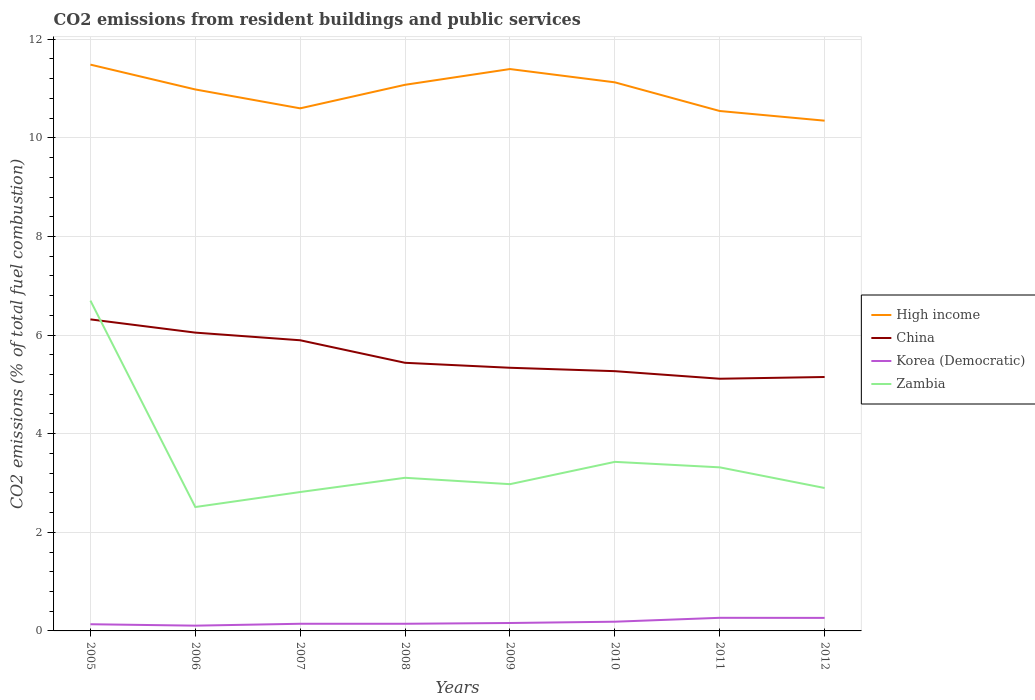Is the number of lines equal to the number of legend labels?
Provide a succinct answer. Yes. Across all years, what is the maximum total CO2 emitted in High income?
Your answer should be very brief. 10.35. What is the total total CO2 emitted in Zambia in the graph?
Your answer should be very brief. -0.45. What is the difference between the highest and the second highest total CO2 emitted in China?
Your answer should be very brief. 1.2. What is the difference between the highest and the lowest total CO2 emitted in Korea (Democratic)?
Offer a terse response. 3. How many years are there in the graph?
Keep it short and to the point. 8. What is the difference between two consecutive major ticks on the Y-axis?
Your answer should be compact. 2. Are the values on the major ticks of Y-axis written in scientific E-notation?
Keep it short and to the point. No. Does the graph contain grids?
Provide a short and direct response. Yes. Where does the legend appear in the graph?
Offer a very short reply. Center right. How are the legend labels stacked?
Your answer should be compact. Vertical. What is the title of the graph?
Your response must be concise. CO2 emissions from resident buildings and public services. Does "Sint Maarten (Dutch part)" appear as one of the legend labels in the graph?
Provide a succinct answer. No. What is the label or title of the X-axis?
Your response must be concise. Years. What is the label or title of the Y-axis?
Offer a terse response. CO2 emissions (% of total fuel combustion). What is the CO2 emissions (% of total fuel combustion) of High income in 2005?
Keep it short and to the point. 11.48. What is the CO2 emissions (% of total fuel combustion) of China in 2005?
Provide a succinct answer. 6.32. What is the CO2 emissions (% of total fuel combustion) of Korea (Democratic) in 2005?
Give a very brief answer. 0.14. What is the CO2 emissions (% of total fuel combustion) in Zambia in 2005?
Ensure brevity in your answer.  6.7. What is the CO2 emissions (% of total fuel combustion) of High income in 2006?
Your answer should be very brief. 10.98. What is the CO2 emissions (% of total fuel combustion) of China in 2006?
Keep it short and to the point. 6.05. What is the CO2 emissions (% of total fuel combustion) in Korea (Democratic) in 2006?
Your answer should be compact. 0.11. What is the CO2 emissions (% of total fuel combustion) of Zambia in 2006?
Ensure brevity in your answer.  2.51. What is the CO2 emissions (% of total fuel combustion) of High income in 2007?
Offer a terse response. 10.6. What is the CO2 emissions (% of total fuel combustion) of China in 2007?
Your answer should be compact. 5.89. What is the CO2 emissions (% of total fuel combustion) of Korea (Democratic) in 2007?
Give a very brief answer. 0.15. What is the CO2 emissions (% of total fuel combustion) of Zambia in 2007?
Your answer should be compact. 2.82. What is the CO2 emissions (% of total fuel combustion) of High income in 2008?
Provide a succinct answer. 11.08. What is the CO2 emissions (% of total fuel combustion) in China in 2008?
Make the answer very short. 5.44. What is the CO2 emissions (% of total fuel combustion) of Korea (Democratic) in 2008?
Your answer should be compact. 0.15. What is the CO2 emissions (% of total fuel combustion) in Zambia in 2008?
Your response must be concise. 3.11. What is the CO2 emissions (% of total fuel combustion) in High income in 2009?
Make the answer very short. 11.4. What is the CO2 emissions (% of total fuel combustion) of China in 2009?
Ensure brevity in your answer.  5.34. What is the CO2 emissions (% of total fuel combustion) of Korea (Democratic) in 2009?
Keep it short and to the point. 0.16. What is the CO2 emissions (% of total fuel combustion) in Zambia in 2009?
Offer a terse response. 2.98. What is the CO2 emissions (% of total fuel combustion) in High income in 2010?
Your answer should be compact. 11.13. What is the CO2 emissions (% of total fuel combustion) in China in 2010?
Your response must be concise. 5.27. What is the CO2 emissions (% of total fuel combustion) of Korea (Democratic) in 2010?
Your answer should be very brief. 0.19. What is the CO2 emissions (% of total fuel combustion) of Zambia in 2010?
Your answer should be compact. 3.43. What is the CO2 emissions (% of total fuel combustion) in High income in 2011?
Ensure brevity in your answer.  10.54. What is the CO2 emissions (% of total fuel combustion) in China in 2011?
Give a very brief answer. 5.11. What is the CO2 emissions (% of total fuel combustion) in Korea (Democratic) in 2011?
Your response must be concise. 0.27. What is the CO2 emissions (% of total fuel combustion) of Zambia in 2011?
Offer a terse response. 3.32. What is the CO2 emissions (% of total fuel combustion) of High income in 2012?
Offer a terse response. 10.35. What is the CO2 emissions (% of total fuel combustion) in China in 2012?
Ensure brevity in your answer.  5.15. What is the CO2 emissions (% of total fuel combustion) in Korea (Democratic) in 2012?
Ensure brevity in your answer.  0.26. What is the CO2 emissions (% of total fuel combustion) of Zambia in 2012?
Your answer should be compact. 2.9. Across all years, what is the maximum CO2 emissions (% of total fuel combustion) of High income?
Make the answer very short. 11.48. Across all years, what is the maximum CO2 emissions (% of total fuel combustion) of China?
Make the answer very short. 6.32. Across all years, what is the maximum CO2 emissions (% of total fuel combustion) in Korea (Democratic)?
Ensure brevity in your answer.  0.27. Across all years, what is the maximum CO2 emissions (% of total fuel combustion) in Zambia?
Make the answer very short. 6.7. Across all years, what is the minimum CO2 emissions (% of total fuel combustion) of High income?
Keep it short and to the point. 10.35. Across all years, what is the minimum CO2 emissions (% of total fuel combustion) in China?
Your answer should be compact. 5.11. Across all years, what is the minimum CO2 emissions (% of total fuel combustion) in Korea (Democratic)?
Offer a terse response. 0.11. Across all years, what is the minimum CO2 emissions (% of total fuel combustion) of Zambia?
Your answer should be compact. 2.51. What is the total CO2 emissions (% of total fuel combustion) in High income in the graph?
Offer a terse response. 87.55. What is the total CO2 emissions (% of total fuel combustion) in China in the graph?
Your answer should be compact. 44.57. What is the total CO2 emissions (% of total fuel combustion) of Korea (Democratic) in the graph?
Give a very brief answer. 1.41. What is the total CO2 emissions (% of total fuel combustion) of Zambia in the graph?
Your answer should be compact. 27.75. What is the difference between the CO2 emissions (% of total fuel combustion) in High income in 2005 and that in 2006?
Keep it short and to the point. 0.5. What is the difference between the CO2 emissions (% of total fuel combustion) in China in 2005 and that in 2006?
Keep it short and to the point. 0.27. What is the difference between the CO2 emissions (% of total fuel combustion) of Korea (Democratic) in 2005 and that in 2006?
Ensure brevity in your answer.  0.03. What is the difference between the CO2 emissions (% of total fuel combustion) of Zambia in 2005 and that in 2006?
Your response must be concise. 4.19. What is the difference between the CO2 emissions (% of total fuel combustion) of High income in 2005 and that in 2007?
Your response must be concise. 0.89. What is the difference between the CO2 emissions (% of total fuel combustion) in China in 2005 and that in 2007?
Give a very brief answer. 0.42. What is the difference between the CO2 emissions (% of total fuel combustion) of Korea (Democratic) in 2005 and that in 2007?
Give a very brief answer. -0.01. What is the difference between the CO2 emissions (% of total fuel combustion) of Zambia in 2005 and that in 2007?
Your response must be concise. 3.88. What is the difference between the CO2 emissions (% of total fuel combustion) of High income in 2005 and that in 2008?
Ensure brevity in your answer.  0.41. What is the difference between the CO2 emissions (% of total fuel combustion) in China in 2005 and that in 2008?
Provide a short and direct response. 0.88. What is the difference between the CO2 emissions (% of total fuel combustion) of Korea (Democratic) in 2005 and that in 2008?
Ensure brevity in your answer.  -0.01. What is the difference between the CO2 emissions (% of total fuel combustion) in Zambia in 2005 and that in 2008?
Ensure brevity in your answer.  3.59. What is the difference between the CO2 emissions (% of total fuel combustion) in High income in 2005 and that in 2009?
Offer a terse response. 0.09. What is the difference between the CO2 emissions (% of total fuel combustion) of China in 2005 and that in 2009?
Offer a very short reply. 0.98. What is the difference between the CO2 emissions (% of total fuel combustion) in Korea (Democratic) in 2005 and that in 2009?
Provide a succinct answer. -0.03. What is the difference between the CO2 emissions (% of total fuel combustion) in Zambia in 2005 and that in 2009?
Keep it short and to the point. 3.72. What is the difference between the CO2 emissions (% of total fuel combustion) of High income in 2005 and that in 2010?
Provide a short and direct response. 0.36. What is the difference between the CO2 emissions (% of total fuel combustion) of China in 2005 and that in 2010?
Ensure brevity in your answer.  1.05. What is the difference between the CO2 emissions (% of total fuel combustion) of Korea (Democratic) in 2005 and that in 2010?
Ensure brevity in your answer.  -0.05. What is the difference between the CO2 emissions (% of total fuel combustion) in Zambia in 2005 and that in 2010?
Give a very brief answer. 3.27. What is the difference between the CO2 emissions (% of total fuel combustion) in High income in 2005 and that in 2011?
Your answer should be very brief. 0.94. What is the difference between the CO2 emissions (% of total fuel combustion) in China in 2005 and that in 2011?
Ensure brevity in your answer.  1.2. What is the difference between the CO2 emissions (% of total fuel combustion) in Korea (Democratic) in 2005 and that in 2011?
Offer a terse response. -0.13. What is the difference between the CO2 emissions (% of total fuel combustion) of Zambia in 2005 and that in 2011?
Offer a terse response. 3.38. What is the difference between the CO2 emissions (% of total fuel combustion) of High income in 2005 and that in 2012?
Your answer should be compact. 1.14. What is the difference between the CO2 emissions (% of total fuel combustion) in China in 2005 and that in 2012?
Provide a short and direct response. 1.17. What is the difference between the CO2 emissions (% of total fuel combustion) of Korea (Democratic) in 2005 and that in 2012?
Ensure brevity in your answer.  -0.13. What is the difference between the CO2 emissions (% of total fuel combustion) in Zambia in 2005 and that in 2012?
Offer a very short reply. 3.8. What is the difference between the CO2 emissions (% of total fuel combustion) in High income in 2006 and that in 2007?
Your answer should be compact. 0.38. What is the difference between the CO2 emissions (% of total fuel combustion) in China in 2006 and that in 2007?
Provide a succinct answer. 0.16. What is the difference between the CO2 emissions (% of total fuel combustion) in Korea (Democratic) in 2006 and that in 2007?
Ensure brevity in your answer.  -0.04. What is the difference between the CO2 emissions (% of total fuel combustion) in Zambia in 2006 and that in 2007?
Offer a very short reply. -0.3. What is the difference between the CO2 emissions (% of total fuel combustion) in High income in 2006 and that in 2008?
Your response must be concise. -0.09. What is the difference between the CO2 emissions (% of total fuel combustion) in China in 2006 and that in 2008?
Offer a very short reply. 0.61. What is the difference between the CO2 emissions (% of total fuel combustion) of Korea (Democratic) in 2006 and that in 2008?
Keep it short and to the point. -0.04. What is the difference between the CO2 emissions (% of total fuel combustion) in Zambia in 2006 and that in 2008?
Ensure brevity in your answer.  -0.59. What is the difference between the CO2 emissions (% of total fuel combustion) in High income in 2006 and that in 2009?
Your answer should be compact. -0.41. What is the difference between the CO2 emissions (% of total fuel combustion) of China in 2006 and that in 2009?
Provide a succinct answer. 0.71. What is the difference between the CO2 emissions (% of total fuel combustion) of Korea (Democratic) in 2006 and that in 2009?
Offer a very short reply. -0.05. What is the difference between the CO2 emissions (% of total fuel combustion) in Zambia in 2006 and that in 2009?
Provide a short and direct response. -0.46. What is the difference between the CO2 emissions (% of total fuel combustion) in High income in 2006 and that in 2010?
Provide a short and direct response. -0.14. What is the difference between the CO2 emissions (% of total fuel combustion) in China in 2006 and that in 2010?
Provide a short and direct response. 0.78. What is the difference between the CO2 emissions (% of total fuel combustion) of Korea (Democratic) in 2006 and that in 2010?
Offer a very short reply. -0.08. What is the difference between the CO2 emissions (% of total fuel combustion) of Zambia in 2006 and that in 2010?
Your response must be concise. -0.92. What is the difference between the CO2 emissions (% of total fuel combustion) of High income in 2006 and that in 2011?
Offer a very short reply. 0.44. What is the difference between the CO2 emissions (% of total fuel combustion) in China in 2006 and that in 2011?
Your response must be concise. 0.94. What is the difference between the CO2 emissions (% of total fuel combustion) in Korea (Democratic) in 2006 and that in 2011?
Ensure brevity in your answer.  -0.16. What is the difference between the CO2 emissions (% of total fuel combustion) in Zambia in 2006 and that in 2011?
Ensure brevity in your answer.  -0.81. What is the difference between the CO2 emissions (% of total fuel combustion) of High income in 2006 and that in 2012?
Keep it short and to the point. 0.63. What is the difference between the CO2 emissions (% of total fuel combustion) of China in 2006 and that in 2012?
Provide a succinct answer. 0.9. What is the difference between the CO2 emissions (% of total fuel combustion) of Korea (Democratic) in 2006 and that in 2012?
Make the answer very short. -0.16. What is the difference between the CO2 emissions (% of total fuel combustion) of Zambia in 2006 and that in 2012?
Offer a terse response. -0.39. What is the difference between the CO2 emissions (% of total fuel combustion) of High income in 2007 and that in 2008?
Your answer should be compact. -0.48. What is the difference between the CO2 emissions (% of total fuel combustion) of China in 2007 and that in 2008?
Your answer should be compact. 0.46. What is the difference between the CO2 emissions (% of total fuel combustion) in Korea (Democratic) in 2007 and that in 2008?
Offer a terse response. 0. What is the difference between the CO2 emissions (% of total fuel combustion) in Zambia in 2007 and that in 2008?
Provide a short and direct response. -0.29. What is the difference between the CO2 emissions (% of total fuel combustion) in High income in 2007 and that in 2009?
Provide a short and direct response. -0.8. What is the difference between the CO2 emissions (% of total fuel combustion) of China in 2007 and that in 2009?
Ensure brevity in your answer.  0.56. What is the difference between the CO2 emissions (% of total fuel combustion) of Korea (Democratic) in 2007 and that in 2009?
Provide a short and direct response. -0.02. What is the difference between the CO2 emissions (% of total fuel combustion) of Zambia in 2007 and that in 2009?
Ensure brevity in your answer.  -0.16. What is the difference between the CO2 emissions (% of total fuel combustion) in High income in 2007 and that in 2010?
Make the answer very short. -0.53. What is the difference between the CO2 emissions (% of total fuel combustion) in China in 2007 and that in 2010?
Keep it short and to the point. 0.63. What is the difference between the CO2 emissions (% of total fuel combustion) in Korea (Democratic) in 2007 and that in 2010?
Your answer should be very brief. -0.04. What is the difference between the CO2 emissions (% of total fuel combustion) of Zambia in 2007 and that in 2010?
Your answer should be very brief. -0.61. What is the difference between the CO2 emissions (% of total fuel combustion) of High income in 2007 and that in 2011?
Provide a succinct answer. 0.05. What is the difference between the CO2 emissions (% of total fuel combustion) of China in 2007 and that in 2011?
Offer a terse response. 0.78. What is the difference between the CO2 emissions (% of total fuel combustion) in Korea (Democratic) in 2007 and that in 2011?
Your response must be concise. -0.12. What is the difference between the CO2 emissions (% of total fuel combustion) in Zambia in 2007 and that in 2011?
Give a very brief answer. -0.5. What is the difference between the CO2 emissions (% of total fuel combustion) of High income in 2007 and that in 2012?
Offer a terse response. 0.25. What is the difference between the CO2 emissions (% of total fuel combustion) of China in 2007 and that in 2012?
Offer a terse response. 0.74. What is the difference between the CO2 emissions (% of total fuel combustion) in Korea (Democratic) in 2007 and that in 2012?
Ensure brevity in your answer.  -0.12. What is the difference between the CO2 emissions (% of total fuel combustion) in Zambia in 2007 and that in 2012?
Your response must be concise. -0.08. What is the difference between the CO2 emissions (% of total fuel combustion) of High income in 2008 and that in 2009?
Provide a short and direct response. -0.32. What is the difference between the CO2 emissions (% of total fuel combustion) of China in 2008 and that in 2009?
Offer a terse response. 0.1. What is the difference between the CO2 emissions (% of total fuel combustion) in Korea (Democratic) in 2008 and that in 2009?
Your answer should be compact. -0.02. What is the difference between the CO2 emissions (% of total fuel combustion) in Zambia in 2008 and that in 2009?
Make the answer very short. 0.13. What is the difference between the CO2 emissions (% of total fuel combustion) in High income in 2008 and that in 2010?
Provide a succinct answer. -0.05. What is the difference between the CO2 emissions (% of total fuel combustion) in China in 2008 and that in 2010?
Offer a very short reply. 0.17. What is the difference between the CO2 emissions (% of total fuel combustion) of Korea (Democratic) in 2008 and that in 2010?
Provide a short and direct response. -0.04. What is the difference between the CO2 emissions (% of total fuel combustion) of Zambia in 2008 and that in 2010?
Make the answer very short. -0.32. What is the difference between the CO2 emissions (% of total fuel combustion) of High income in 2008 and that in 2011?
Give a very brief answer. 0.53. What is the difference between the CO2 emissions (% of total fuel combustion) in China in 2008 and that in 2011?
Offer a terse response. 0.32. What is the difference between the CO2 emissions (% of total fuel combustion) of Korea (Democratic) in 2008 and that in 2011?
Your response must be concise. -0.12. What is the difference between the CO2 emissions (% of total fuel combustion) in Zambia in 2008 and that in 2011?
Your answer should be compact. -0.21. What is the difference between the CO2 emissions (% of total fuel combustion) of High income in 2008 and that in 2012?
Your answer should be compact. 0.73. What is the difference between the CO2 emissions (% of total fuel combustion) of China in 2008 and that in 2012?
Offer a very short reply. 0.29. What is the difference between the CO2 emissions (% of total fuel combustion) of Korea (Democratic) in 2008 and that in 2012?
Your answer should be very brief. -0.12. What is the difference between the CO2 emissions (% of total fuel combustion) in Zambia in 2008 and that in 2012?
Your response must be concise. 0.21. What is the difference between the CO2 emissions (% of total fuel combustion) in High income in 2009 and that in 2010?
Offer a terse response. 0.27. What is the difference between the CO2 emissions (% of total fuel combustion) of China in 2009 and that in 2010?
Offer a terse response. 0.07. What is the difference between the CO2 emissions (% of total fuel combustion) in Korea (Democratic) in 2009 and that in 2010?
Your answer should be very brief. -0.03. What is the difference between the CO2 emissions (% of total fuel combustion) in Zambia in 2009 and that in 2010?
Give a very brief answer. -0.45. What is the difference between the CO2 emissions (% of total fuel combustion) in High income in 2009 and that in 2011?
Your response must be concise. 0.85. What is the difference between the CO2 emissions (% of total fuel combustion) in China in 2009 and that in 2011?
Offer a terse response. 0.22. What is the difference between the CO2 emissions (% of total fuel combustion) of Korea (Democratic) in 2009 and that in 2011?
Offer a very short reply. -0.11. What is the difference between the CO2 emissions (% of total fuel combustion) in Zambia in 2009 and that in 2011?
Your answer should be very brief. -0.34. What is the difference between the CO2 emissions (% of total fuel combustion) of High income in 2009 and that in 2012?
Offer a terse response. 1.05. What is the difference between the CO2 emissions (% of total fuel combustion) in China in 2009 and that in 2012?
Provide a succinct answer. 0.19. What is the difference between the CO2 emissions (% of total fuel combustion) in Korea (Democratic) in 2009 and that in 2012?
Your answer should be compact. -0.1. What is the difference between the CO2 emissions (% of total fuel combustion) of Zambia in 2009 and that in 2012?
Your response must be concise. 0.08. What is the difference between the CO2 emissions (% of total fuel combustion) in High income in 2010 and that in 2011?
Your response must be concise. 0.58. What is the difference between the CO2 emissions (% of total fuel combustion) in China in 2010 and that in 2011?
Provide a succinct answer. 0.15. What is the difference between the CO2 emissions (% of total fuel combustion) in Korea (Democratic) in 2010 and that in 2011?
Your answer should be compact. -0.08. What is the difference between the CO2 emissions (% of total fuel combustion) in Zambia in 2010 and that in 2011?
Your answer should be compact. 0.11. What is the difference between the CO2 emissions (% of total fuel combustion) of High income in 2010 and that in 2012?
Give a very brief answer. 0.78. What is the difference between the CO2 emissions (% of total fuel combustion) of China in 2010 and that in 2012?
Provide a short and direct response. 0.12. What is the difference between the CO2 emissions (% of total fuel combustion) in Korea (Democratic) in 2010 and that in 2012?
Your answer should be compact. -0.08. What is the difference between the CO2 emissions (% of total fuel combustion) in Zambia in 2010 and that in 2012?
Your response must be concise. 0.53. What is the difference between the CO2 emissions (% of total fuel combustion) in High income in 2011 and that in 2012?
Provide a short and direct response. 0.2. What is the difference between the CO2 emissions (% of total fuel combustion) in China in 2011 and that in 2012?
Provide a short and direct response. -0.04. What is the difference between the CO2 emissions (% of total fuel combustion) in Korea (Democratic) in 2011 and that in 2012?
Give a very brief answer. 0. What is the difference between the CO2 emissions (% of total fuel combustion) in Zambia in 2011 and that in 2012?
Your answer should be very brief. 0.42. What is the difference between the CO2 emissions (% of total fuel combustion) in High income in 2005 and the CO2 emissions (% of total fuel combustion) in China in 2006?
Offer a very short reply. 5.43. What is the difference between the CO2 emissions (% of total fuel combustion) of High income in 2005 and the CO2 emissions (% of total fuel combustion) of Korea (Democratic) in 2006?
Give a very brief answer. 11.38. What is the difference between the CO2 emissions (% of total fuel combustion) of High income in 2005 and the CO2 emissions (% of total fuel combustion) of Zambia in 2006?
Your response must be concise. 8.97. What is the difference between the CO2 emissions (% of total fuel combustion) of China in 2005 and the CO2 emissions (% of total fuel combustion) of Korea (Democratic) in 2006?
Offer a very short reply. 6.21. What is the difference between the CO2 emissions (% of total fuel combustion) of China in 2005 and the CO2 emissions (% of total fuel combustion) of Zambia in 2006?
Offer a terse response. 3.81. What is the difference between the CO2 emissions (% of total fuel combustion) in Korea (Democratic) in 2005 and the CO2 emissions (% of total fuel combustion) in Zambia in 2006?
Keep it short and to the point. -2.38. What is the difference between the CO2 emissions (% of total fuel combustion) of High income in 2005 and the CO2 emissions (% of total fuel combustion) of China in 2007?
Your answer should be very brief. 5.59. What is the difference between the CO2 emissions (% of total fuel combustion) in High income in 2005 and the CO2 emissions (% of total fuel combustion) in Korea (Democratic) in 2007?
Offer a terse response. 11.34. What is the difference between the CO2 emissions (% of total fuel combustion) of High income in 2005 and the CO2 emissions (% of total fuel combustion) of Zambia in 2007?
Ensure brevity in your answer.  8.67. What is the difference between the CO2 emissions (% of total fuel combustion) in China in 2005 and the CO2 emissions (% of total fuel combustion) in Korea (Democratic) in 2007?
Provide a succinct answer. 6.17. What is the difference between the CO2 emissions (% of total fuel combustion) in China in 2005 and the CO2 emissions (% of total fuel combustion) in Zambia in 2007?
Keep it short and to the point. 3.5. What is the difference between the CO2 emissions (% of total fuel combustion) of Korea (Democratic) in 2005 and the CO2 emissions (% of total fuel combustion) of Zambia in 2007?
Offer a terse response. -2.68. What is the difference between the CO2 emissions (% of total fuel combustion) in High income in 2005 and the CO2 emissions (% of total fuel combustion) in China in 2008?
Make the answer very short. 6.05. What is the difference between the CO2 emissions (% of total fuel combustion) of High income in 2005 and the CO2 emissions (% of total fuel combustion) of Korea (Democratic) in 2008?
Offer a terse response. 11.34. What is the difference between the CO2 emissions (% of total fuel combustion) of High income in 2005 and the CO2 emissions (% of total fuel combustion) of Zambia in 2008?
Provide a succinct answer. 8.38. What is the difference between the CO2 emissions (% of total fuel combustion) in China in 2005 and the CO2 emissions (% of total fuel combustion) in Korea (Democratic) in 2008?
Your response must be concise. 6.17. What is the difference between the CO2 emissions (% of total fuel combustion) of China in 2005 and the CO2 emissions (% of total fuel combustion) of Zambia in 2008?
Your response must be concise. 3.21. What is the difference between the CO2 emissions (% of total fuel combustion) in Korea (Democratic) in 2005 and the CO2 emissions (% of total fuel combustion) in Zambia in 2008?
Your answer should be very brief. -2.97. What is the difference between the CO2 emissions (% of total fuel combustion) in High income in 2005 and the CO2 emissions (% of total fuel combustion) in China in 2009?
Ensure brevity in your answer.  6.15. What is the difference between the CO2 emissions (% of total fuel combustion) in High income in 2005 and the CO2 emissions (% of total fuel combustion) in Korea (Democratic) in 2009?
Your answer should be compact. 11.32. What is the difference between the CO2 emissions (% of total fuel combustion) of High income in 2005 and the CO2 emissions (% of total fuel combustion) of Zambia in 2009?
Keep it short and to the point. 8.51. What is the difference between the CO2 emissions (% of total fuel combustion) in China in 2005 and the CO2 emissions (% of total fuel combustion) in Korea (Democratic) in 2009?
Your answer should be very brief. 6.16. What is the difference between the CO2 emissions (% of total fuel combustion) in China in 2005 and the CO2 emissions (% of total fuel combustion) in Zambia in 2009?
Your response must be concise. 3.34. What is the difference between the CO2 emissions (% of total fuel combustion) of Korea (Democratic) in 2005 and the CO2 emissions (% of total fuel combustion) of Zambia in 2009?
Make the answer very short. -2.84. What is the difference between the CO2 emissions (% of total fuel combustion) of High income in 2005 and the CO2 emissions (% of total fuel combustion) of China in 2010?
Provide a short and direct response. 6.22. What is the difference between the CO2 emissions (% of total fuel combustion) in High income in 2005 and the CO2 emissions (% of total fuel combustion) in Korea (Democratic) in 2010?
Ensure brevity in your answer.  11.3. What is the difference between the CO2 emissions (% of total fuel combustion) of High income in 2005 and the CO2 emissions (% of total fuel combustion) of Zambia in 2010?
Provide a short and direct response. 8.06. What is the difference between the CO2 emissions (% of total fuel combustion) in China in 2005 and the CO2 emissions (% of total fuel combustion) in Korea (Democratic) in 2010?
Your answer should be compact. 6.13. What is the difference between the CO2 emissions (% of total fuel combustion) in China in 2005 and the CO2 emissions (% of total fuel combustion) in Zambia in 2010?
Your answer should be very brief. 2.89. What is the difference between the CO2 emissions (% of total fuel combustion) in Korea (Democratic) in 2005 and the CO2 emissions (% of total fuel combustion) in Zambia in 2010?
Give a very brief answer. -3.29. What is the difference between the CO2 emissions (% of total fuel combustion) of High income in 2005 and the CO2 emissions (% of total fuel combustion) of China in 2011?
Your answer should be very brief. 6.37. What is the difference between the CO2 emissions (% of total fuel combustion) of High income in 2005 and the CO2 emissions (% of total fuel combustion) of Korea (Democratic) in 2011?
Make the answer very short. 11.22. What is the difference between the CO2 emissions (% of total fuel combustion) of High income in 2005 and the CO2 emissions (% of total fuel combustion) of Zambia in 2011?
Offer a terse response. 8.17. What is the difference between the CO2 emissions (% of total fuel combustion) in China in 2005 and the CO2 emissions (% of total fuel combustion) in Korea (Democratic) in 2011?
Your answer should be very brief. 6.05. What is the difference between the CO2 emissions (% of total fuel combustion) in China in 2005 and the CO2 emissions (% of total fuel combustion) in Zambia in 2011?
Ensure brevity in your answer.  3. What is the difference between the CO2 emissions (% of total fuel combustion) in Korea (Democratic) in 2005 and the CO2 emissions (% of total fuel combustion) in Zambia in 2011?
Ensure brevity in your answer.  -3.18. What is the difference between the CO2 emissions (% of total fuel combustion) of High income in 2005 and the CO2 emissions (% of total fuel combustion) of China in 2012?
Offer a terse response. 6.33. What is the difference between the CO2 emissions (% of total fuel combustion) in High income in 2005 and the CO2 emissions (% of total fuel combustion) in Korea (Democratic) in 2012?
Offer a very short reply. 11.22. What is the difference between the CO2 emissions (% of total fuel combustion) in High income in 2005 and the CO2 emissions (% of total fuel combustion) in Zambia in 2012?
Give a very brief answer. 8.59. What is the difference between the CO2 emissions (% of total fuel combustion) of China in 2005 and the CO2 emissions (% of total fuel combustion) of Korea (Democratic) in 2012?
Offer a very short reply. 6.05. What is the difference between the CO2 emissions (% of total fuel combustion) of China in 2005 and the CO2 emissions (% of total fuel combustion) of Zambia in 2012?
Keep it short and to the point. 3.42. What is the difference between the CO2 emissions (% of total fuel combustion) of Korea (Democratic) in 2005 and the CO2 emissions (% of total fuel combustion) of Zambia in 2012?
Offer a very short reply. -2.76. What is the difference between the CO2 emissions (% of total fuel combustion) of High income in 2006 and the CO2 emissions (% of total fuel combustion) of China in 2007?
Make the answer very short. 5.09. What is the difference between the CO2 emissions (% of total fuel combustion) in High income in 2006 and the CO2 emissions (% of total fuel combustion) in Korea (Democratic) in 2007?
Offer a terse response. 10.84. What is the difference between the CO2 emissions (% of total fuel combustion) in High income in 2006 and the CO2 emissions (% of total fuel combustion) in Zambia in 2007?
Provide a succinct answer. 8.16. What is the difference between the CO2 emissions (% of total fuel combustion) in China in 2006 and the CO2 emissions (% of total fuel combustion) in Korea (Democratic) in 2007?
Offer a terse response. 5.9. What is the difference between the CO2 emissions (% of total fuel combustion) of China in 2006 and the CO2 emissions (% of total fuel combustion) of Zambia in 2007?
Your response must be concise. 3.23. What is the difference between the CO2 emissions (% of total fuel combustion) of Korea (Democratic) in 2006 and the CO2 emissions (% of total fuel combustion) of Zambia in 2007?
Give a very brief answer. -2.71. What is the difference between the CO2 emissions (% of total fuel combustion) of High income in 2006 and the CO2 emissions (% of total fuel combustion) of China in 2008?
Ensure brevity in your answer.  5.54. What is the difference between the CO2 emissions (% of total fuel combustion) in High income in 2006 and the CO2 emissions (% of total fuel combustion) in Korea (Democratic) in 2008?
Make the answer very short. 10.84. What is the difference between the CO2 emissions (% of total fuel combustion) in High income in 2006 and the CO2 emissions (% of total fuel combustion) in Zambia in 2008?
Ensure brevity in your answer.  7.88. What is the difference between the CO2 emissions (% of total fuel combustion) in China in 2006 and the CO2 emissions (% of total fuel combustion) in Korea (Democratic) in 2008?
Ensure brevity in your answer.  5.9. What is the difference between the CO2 emissions (% of total fuel combustion) of China in 2006 and the CO2 emissions (% of total fuel combustion) of Zambia in 2008?
Your response must be concise. 2.94. What is the difference between the CO2 emissions (% of total fuel combustion) in Korea (Democratic) in 2006 and the CO2 emissions (% of total fuel combustion) in Zambia in 2008?
Your answer should be very brief. -3. What is the difference between the CO2 emissions (% of total fuel combustion) of High income in 2006 and the CO2 emissions (% of total fuel combustion) of China in 2009?
Your response must be concise. 5.64. What is the difference between the CO2 emissions (% of total fuel combustion) of High income in 2006 and the CO2 emissions (% of total fuel combustion) of Korea (Democratic) in 2009?
Make the answer very short. 10.82. What is the difference between the CO2 emissions (% of total fuel combustion) of High income in 2006 and the CO2 emissions (% of total fuel combustion) of Zambia in 2009?
Give a very brief answer. 8. What is the difference between the CO2 emissions (% of total fuel combustion) in China in 2006 and the CO2 emissions (% of total fuel combustion) in Korea (Democratic) in 2009?
Make the answer very short. 5.89. What is the difference between the CO2 emissions (% of total fuel combustion) of China in 2006 and the CO2 emissions (% of total fuel combustion) of Zambia in 2009?
Ensure brevity in your answer.  3.07. What is the difference between the CO2 emissions (% of total fuel combustion) in Korea (Democratic) in 2006 and the CO2 emissions (% of total fuel combustion) in Zambia in 2009?
Make the answer very short. -2.87. What is the difference between the CO2 emissions (% of total fuel combustion) in High income in 2006 and the CO2 emissions (% of total fuel combustion) in China in 2010?
Give a very brief answer. 5.71. What is the difference between the CO2 emissions (% of total fuel combustion) of High income in 2006 and the CO2 emissions (% of total fuel combustion) of Korea (Democratic) in 2010?
Your response must be concise. 10.79. What is the difference between the CO2 emissions (% of total fuel combustion) in High income in 2006 and the CO2 emissions (% of total fuel combustion) in Zambia in 2010?
Make the answer very short. 7.55. What is the difference between the CO2 emissions (% of total fuel combustion) of China in 2006 and the CO2 emissions (% of total fuel combustion) of Korea (Democratic) in 2010?
Give a very brief answer. 5.86. What is the difference between the CO2 emissions (% of total fuel combustion) in China in 2006 and the CO2 emissions (% of total fuel combustion) in Zambia in 2010?
Your answer should be very brief. 2.62. What is the difference between the CO2 emissions (% of total fuel combustion) of Korea (Democratic) in 2006 and the CO2 emissions (% of total fuel combustion) of Zambia in 2010?
Your response must be concise. -3.32. What is the difference between the CO2 emissions (% of total fuel combustion) in High income in 2006 and the CO2 emissions (% of total fuel combustion) in China in 2011?
Provide a succinct answer. 5.87. What is the difference between the CO2 emissions (% of total fuel combustion) of High income in 2006 and the CO2 emissions (% of total fuel combustion) of Korea (Democratic) in 2011?
Give a very brief answer. 10.72. What is the difference between the CO2 emissions (% of total fuel combustion) in High income in 2006 and the CO2 emissions (% of total fuel combustion) in Zambia in 2011?
Ensure brevity in your answer.  7.66. What is the difference between the CO2 emissions (% of total fuel combustion) of China in 2006 and the CO2 emissions (% of total fuel combustion) of Korea (Democratic) in 2011?
Provide a short and direct response. 5.78. What is the difference between the CO2 emissions (% of total fuel combustion) of China in 2006 and the CO2 emissions (% of total fuel combustion) of Zambia in 2011?
Make the answer very short. 2.73. What is the difference between the CO2 emissions (% of total fuel combustion) in Korea (Democratic) in 2006 and the CO2 emissions (% of total fuel combustion) in Zambia in 2011?
Offer a very short reply. -3.21. What is the difference between the CO2 emissions (% of total fuel combustion) of High income in 2006 and the CO2 emissions (% of total fuel combustion) of China in 2012?
Offer a very short reply. 5.83. What is the difference between the CO2 emissions (% of total fuel combustion) in High income in 2006 and the CO2 emissions (% of total fuel combustion) in Korea (Democratic) in 2012?
Offer a very short reply. 10.72. What is the difference between the CO2 emissions (% of total fuel combustion) of High income in 2006 and the CO2 emissions (% of total fuel combustion) of Zambia in 2012?
Make the answer very short. 8.08. What is the difference between the CO2 emissions (% of total fuel combustion) of China in 2006 and the CO2 emissions (% of total fuel combustion) of Korea (Democratic) in 2012?
Your answer should be very brief. 5.79. What is the difference between the CO2 emissions (% of total fuel combustion) of China in 2006 and the CO2 emissions (% of total fuel combustion) of Zambia in 2012?
Your answer should be compact. 3.15. What is the difference between the CO2 emissions (% of total fuel combustion) of Korea (Democratic) in 2006 and the CO2 emissions (% of total fuel combustion) of Zambia in 2012?
Your answer should be very brief. -2.79. What is the difference between the CO2 emissions (% of total fuel combustion) of High income in 2007 and the CO2 emissions (% of total fuel combustion) of China in 2008?
Your response must be concise. 5.16. What is the difference between the CO2 emissions (% of total fuel combustion) of High income in 2007 and the CO2 emissions (% of total fuel combustion) of Korea (Democratic) in 2008?
Ensure brevity in your answer.  10.45. What is the difference between the CO2 emissions (% of total fuel combustion) in High income in 2007 and the CO2 emissions (% of total fuel combustion) in Zambia in 2008?
Your response must be concise. 7.49. What is the difference between the CO2 emissions (% of total fuel combustion) in China in 2007 and the CO2 emissions (% of total fuel combustion) in Korea (Democratic) in 2008?
Make the answer very short. 5.75. What is the difference between the CO2 emissions (% of total fuel combustion) of China in 2007 and the CO2 emissions (% of total fuel combustion) of Zambia in 2008?
Your answer should be compact. 2.79. What is the difference between the CO2 emissions (% of total fuel combustion) in Korea (Democratic) in 2007 and the CO2 emissions (% of total fuel combustion) in Zambia in 2008?
Make the answer very short. -2.96. What is the difference between the CO2 emissions (% of total fuel combustion) of High income in 2007 and the CO2 emissions (% of total fuel combustion) of China in 2009?
Provide a succinct answer. 5.26. What is the difference between the CO2 emissions (% of total fuel combustion) in High income in 2007 and the CO2 emissions (% of total fuel combustion) in Korea (Democratic) in 2009?
Your answer should be very brief. 10.44. What is the difference between the CO2 emissions (% of total fuel combustion) of High income in 2007 and the CO2 emissions (% of total fuel combustion) of Zambia in 2009?
Your answer should be compact. 7.62. What is the difference between the CO2 emissions (% of total fuel combustion) of China in 2007 and the CO2 emissions (% of total fuel combustion) of Korea (Democratic) in 2009?
Make the answer very short. 5.73. What is the difference between the CO2 emissions (% of total fuel combustion) in China in 2007 and the CO2 emissions (% of total fuel combustion) in Zambia in 2009?
Your answer should be compact. 2.92. What is the difference between the CO2 emissions (% of total fuel combustion) of Korea (Democratic) in 2007 and the CO2 emissions (% of total fuel combustion) of Zambia in 2009?
Provide a succinct answer. -2.83. What is the difference between the CO2 emissions (% of total fuel combustion) in High income in 2007 and the CO2 emissions (% of total fuel combustion) in China in 2010?
Ensure brevity in your answer.  5.33. What is the difference between the CO2 emissions (% of total fuel combustion) of High income in 2007 and the CO2 emissions (% of total fuel combustion) of Korea (Democratic) in 2010?
Your answer should be very brief. 10.41. What is the difference between the CO2 emissions (% of total fuel combustion) in High income in 2007 and the CO2 emissions (% of total fuel combustion) in Zambia in 2010?
Give a very brief answer. 7.17. What is the difference between the CO2 emissions (% of total fuel combustion) of China in 2007 and the CO2 emissions (% of total fuel combustion) of Korea (Democratic) in 2010?
Your answer should be very brief. 5.71. What is the difference between the CO2 emissions (% of total fuel combustion) of China in 2007 and the CO2 emissions (% of total fuel combustion) of Zambia in 2010?
Provide a short and direct response. 2.47. What is the difference between the CO2 emissions (% of total fuel combustion) in Korea (Democratic) in 2007 and the CO2 emissions (% of total fuel combustion) in Zambia in 2010?
Give a very brief answer. -3.28. What is the difference between the CO2 emissions (% of total fuel combustion) in High income in 2007 and the CO2 emissions (% of total fuel combustion) in China in 2011?
Offer a terse response. 5.48. What is the difference between the CO2 emissions (% of total fuel combustion) of High income in 2007 and the CO2 emissions (% of total fuel combustion) of Korea (Democratic) in 2011?
Give a very brief answer. 10.33. What is the difference between the CO2 emissions (% of total fuel combustion) in High income in 2007 and the CO2 emissions (% of total fuel combustion) in Zambia in 2011?
Provide a succinct answer. 7.28. What is the difference between the CO2 emissions (% of total fuel combustion) in China in 2007 and the CO2 emissions (% of total fuel combustion) in Korea (Democratic) in 2011?
Your response must be concise. 5.63. What is the difference between the CO2 emissions (% of total fuel combustion) of China in 2007 and the CO2 emissions (% of total fuel combustion) of Zambia in 2011?
Your response must be concise. 2.58. What is the difference between the CO2 emissions (% of total fuel combustion) of Korea (Democratic) in 2007 and the CO2 emissions (% of total fuel combustion) of Zambia in 2011?
Offer a terse response. -3.17. What is the difference between the CO2 emissions (% of total fuel combustion) of High income in 2007 and the CO2 emissions (% of total fuel combustion) of China in 2012?
Your answer should be very brief. 5.45. What is the difference between the CO2 emissions (% of total fuel combustion) of High income in 2007 and the CO2 emissions (% of total fuel combustion) of Korea (Democratic) in 2012?
Your answer should be very brief. 10.33. What is the difference between the CO2 emissions (% of total fuel combustion) of High income in 2007 and the CO2 emissions (% of total fuel combustion) of Zambia in 2012?
Keep it short and to the point. 7.7. What is the difference between the CO2 emissions (% of total fuel combustion) in China in 2007 and the CO2 emissions (% of total fuel combustion) in Korea (Democratic) in 2012?
Provide a succinct answer. 5.63. What is the difference between the CO2 emissions (% of total fuel combustion) in China in 2007 and the CO2 emissions (% of total fuel combustion) in Zambia in 2012?
Offer a terse response. 3. What is the difference between the CO2 emissions (% of total fuel combustion) in Korea (Democratic) in 2007 and the CO2 emissions (% of total fuel combustion) in Zambia in 2012?
Ensure brevity in your answer.  -2.75. What is the difference between the CO2 emissions (% of total fuel combustion) in High income in 2008 and the CO2 emissions (% of total fuel combustion) in China in 2009?
Provide a short and direct response. 5.74. What is the difference between the CO2 emissions (% of total fuel combustion) of High income in 2008 and the CO2 emissions (% of total fuel combustion) of Korea (Democratic) in 2009?
Give a very brief answer. 10.92. What is the difference between the CO2 emissions (% of total fuel combustion) in High income in 2008 and the CO2 emissions (% of total fuel combustion) in Zambia in 2009?
Your answer should be very brief. 8.1. What is the difference between the CO2 emissions (% of total fuel combustion) in China in 2008 and the CO2 emissions (% of total fuel combustion) in Korea (Democratic) in 2009?
Provide a succinct answer. 5.28. What is the difference between the CO2 emissions (% of total fuel combustion) in China in 2008 and the CO2 emissions (% of total fuel combustion) in Zambia in 2009?
Make the answer very short. 2.46. What is the difference between the CO2 emissions (% of total fuel combustion) in Korea (Democratic) in 2008 and the CO2 emissions (% of total fuel combustion) in Zambia in 2009?
Keep it short and to the point. -2.83. What is the difference between the CO2 emissions (% of total fuel combustion) in High income in 2008 and the CO2 emissions (% of total fuel combustion) in China in 2010?
Provide a short and direct response. 5.81. What is the difference between the CO2 emissions (% of total fuel combustion) of High income in 2008 and the CO2 emissions (% of total fuel combustion) of Korea (Democratic) in 2010?
Offer a very short reply. 10.89. What is the difference between the CO2 emissions (% of total fuel combustion) in High income in 2008 and the CO2 emissions (% of total fuel combustion) in Zambia in 2010?
Provide a short and direct response. 7.65. What is the difference between the CO2 emissions (% of total fuel combustion) of China in 2008 and the CO2 emissions (% of total fuel combustion) of Korea (Democratic) in 2010?
Offer a very short reply. 5.25. What is the difference between the CO2 emissions (% of total fuel combustion) of China in 2008 and the CO2 emissions (% of total fuel combustion) of Zambia in 2010?
Ensure brevity in your answer.  2.01. What is the difference between the CO2 emissions (% of total fuel combustion) of Korea (Democratic) in 2008 and the CO2 emissions (% of total fuel combustion) of Zambia in 2010?
Ensure brevity in your answer.  -3.28. What is the difference between the CO2 emissions (% of total fuel combustion) of High income in 2008 and the CO2 emissions (% of total fuel combustion) of China in 2011?
Your answer should be compact. 5.96. What is the difference between the CO2 emissions (% of total fuel combustion) in High income in 2008 and the CO2 emissions (% of total fuel combustion) in Korea (Democratic) in 2011?
Give a very brief answer. 10.81. What is the difference between the CO2 emissions (% of total fuel combustion) in High income in 2008 and the CO2 emissions (% of total fuel combustion) in Zambia in 2011?
Provide a succinct answer. 7.76. What is the difference between the CO2 emissions (% of total fuel combustion) in China in 2008 and the CO2 emissions (% of total fuel combustion) in Korea (Democratic) in 2011?
Provide a succinct answer. 5.17. What is the difference between the CO2 emissions (% of total fuel combustion) of China in 2008 and the CO2 emissions (% of total fuel combustion) of Zambia in 2011?
Make the answer very short. 2.12. What is the difference between the CO2 emissions (% of total fuel combustion) in Korea (Democratic) in 2008 and the CO2 emissions (% of total fuel combustion) in Zambia in 2011?
Ensure brevity in your answer.  -3.17. What is the difference between the CO2 emissions (% of total fuel combustion) in High income in 2008 and the CO2 emissions (% of total fuel combustion) in China in 2012?
Your answer should be very brief. 5.93. What is the difference between the CO2 emissions (% of total fuel combustion) in High income in 2008 and the CO2 emissions (% of total fuel combustion) in Korea (Democratic) in 2012?
Offer a terse response. 10.81. What is the difference between the CO2 emissions (% of total fuel combustion) of High income in 2008 and the CO2 emissions (% of total fuel combustion) of Zambia in 2012?
Your answer should be very brief. 8.18. What is the difference between the CO2 emissions (% of total fuel combustion) of China in 2008 and the CO2 emissions (% of total fuel combustion) of Korea (Democratic) in 2012?
Make the answer very short. 5.17. What is the difference between the CO2 emissions (% of total fuel combustion) in China in 2008 and the CO2 emissions (% of total fuel combustion) in Zambia in 2012?
Your response must be concise. 2.54. What is the difference between the CO2 emissions (% of total fuel combustion) of Korea (Democratic) in 2008 and the CO2 emissions (% of total fuel combustion) of Zambia in 2012?
Your response must be concise. -2.75. What is the difference between the CO2 emissions (% of total fuel combustion) in High income in 2009 and the CO2 emissions (% of total fuel combustion) in China in 2010?
Your response must be concise. 6.13. What is the difference between the CO2 emissions (% of total fuel combustion) of High income in 2009 and the CO2 emissions (% of total fuel combustion) of Korea (Democratic) in 2010?
Give a very brief answer. 11.21. What is the difference between the CO2 emissions (% of total fuel combustion) of High income in 2009 and the CO2 emissions (% of total fuel combustion) of Zambia in 2010?
Provide a succinct answer. 7.97. What is the difference between the CO2 emissions (% of total fuel combustion) of China in 2009 and the CO2 emissions (% of total fuel combustion) of Korea (Democratic) in 2010?
Give a very brief answer. 5.15. What is the difference between the CO2 emissions (% of total fuel combustion) of China in 2009 and the CO2 emissions (% of total fuel combustion) of Zambia in 2010?
Offer a terse response. 1.91. What is the difference between the CO2 emissions (% of total fuel combustion) in Korea (Democratic) in 2009 and the CO2 emissions (% of total fuel combustion) in Zambia in 2010?
Ensure brevity in your answer.  -3.27. What is the difference between the CO2 emissions (% of total fuel combustion) in High income in 2009 and the CO2 emissions (% of total fuel combustion) in China in 2011?
Provide a succinct answer. 6.28. What is the difference between the CO2 emissions (% of total fuel combustion) of High income in 2009 and the CO2 emissions (% of total fuel combustion) of Korea (Democratic) in 2011?
Provide a short and direct response. 11.13. What is the difference between the CO2 emissions (% of total fuel combustion) of High income in 2009 and the CO2 emissions (% of total fuel combustion) of Zambia in 2011?
Make the answer very short. 8.08. What is the difference between the CO2 emissions (% of total fuel combustion) in China in 2009 and the CO2 emissions (% of total fuel combustion) in Korea (Democratic) in 2011?
Make the answer very short. 5.07. What is the difference between the CO2 emissions (% of total fuel combustion) in China in 2009 and the CO2 emissions (% of total fuel combustion) in Zambia in 2011?
Keep it short and to the point. 2.02. What is the difference between the CO2 emissions (% of total fuel combustion) of Korea (Democratic) in 2009 and the CO2 emissions (% of total fuel combustion) of Zambia in 2011?
Your answer should be compact. -3.16. What is the difference between the CO2 emissions (% of total fuel combustion) in High income in 2009 and the CO2 emissions (% of total fuel combustion) in China in 2012?
Your response must be concise. 6.25. What is the difference between the CO2 emissions (% of total fuel combustion) of High income in 2009 and the CO2 emissions (% of total fuel combustion) of Korea (Democratic) in 2012?
Keep it short and to the point. 11.13. What is the difference between the CO2 emissions (% of total fuel combustion) of High income in 2009 and the CO2 emissions (% of total fuel combustion) of Zambia in 2012?
Keep it short and to the point. 8.5. What is the difference between the CO2 emissions (% of total fuel combustion) of China in 2009 and the CO2 emissions (% of total fuel combustion) of Korea (Democratic) in 2012?
Provide a short and direct response. 5.07. What is the difference between the CO2 emissions (% of total fuel combustion) of China in 2009 and the CO2 emissions (% of total fuel combustion) of Zambia in 2012?
Provide a short and direct response. 2.44. What is the difference between the CO2 emissions (% of total fuel combustion) of Korea (Democratic) in 2009 and the CO2 emissions (% of total fuel combustion) of Zambia in 2012?
Make the answer very short. -2.74. What is the difference between the CO2 emissions (% of total fuel combustion) in High income in 2010 and the CO2 emissions (% of total fuel combustion) in China in 2011?
Your answer should be compact. 6.01. What is the difference between the CO2 emissions (% of total fuel combustion) of High income in 2010 and the CO2 emissions (% of total fuel combustion) of Korea (Democratic) in 2011?
Ensure brevity in your answer.  10.86. What is the difference between the CO2 emissions (% of total fuel combustion) in High income in 2010 and the CO2 emissions (% of total fuel combustion) in Zambia in 2011?
Keep it short and to the point. 7.81. What is the difference between the CO2 emissions (% of total fuel combustion) of China in 2010 and the CO2 emissions (% of total fuel combustion) of Korea (Democratic) in 2011?
Ensure brevity in your answer.  5. What is the difference between the CO2 emissions (% of total fuel combustion) of China in 2010 and the CO2 emissions (% of total fuel combustion) of Zambia in 2011?
Ensure brevity in your answer.  1.95. What is the difference between the CO2 emissions (% of total fuel combustion) of Korea (Democratic) in 2010 and the CO2 emissions (% of total fuel combustion) of Zambia in 2011?
Provide a short and direct response. -3.13. What is the difference between the CO2 emissions (% of total fuel combustion) of High income in 2010 and the CO2 emissions (% of total fuel combustion) of China in 2012?
Offer a very short reply. 5.98. What is the difference between the CO2 emissions (% of total fuel combustion) in High income in 2010 and the CO2 emissions (% of total fuel combustion) in Korea (Democratic) in 2012?
Your answer should be very brief. 10.86. What is the difference between the CO2 emissions (% of total fuel combustion) of High income in 2010 and the CO2 emissions (% of total fuel combustion) of Zambia in 2012?
Offer a very short reply. 8.23. What is the difference between the CO2 emissions (% of total fuel combustion) in China in 2010 and the CO2 emissions (% of total fuel combustion) in Korea (Democratic) in 2012?
Provide a short and direct response. 5. What is the difference between the CO2 emissions (% of total fuel combustion) of China in 2010 and the CO2 emissions (% of total fuel combustion) of Zambia in 2012?
Offer a terse response. 2.37. What is the difference between the CO2 emissions (% of total fuel combustion) in Korea (Democratic) in 2010 and the CO2 emissions (% of total fuel combustion) in Zambia in 2012?
Provide a succinct answer. -2.71. What is the difference between the CO2 emissions (% of total fuel combustion) in High income in 2011 and the CO2 emissions (% of total fuel combustion) in China in 2012?
Your answer should be very brief. 5.39. What is the difference between the CO2 emissions (% of total fuel combustion) of High income in 2011 and the CO2 emissions (% of total fuel combustion) of Korea (Democratic) in 2012?
Ensure brevity in your answer.  10.28. What is the difference between the CO2 emissions (% of total fuel combustion) of High income in 2011 and the CO2 emissions (% of total fuel combustion) of Zambia in 2012?
Ensure brevity in your answer.  7.65. What is the difference between the CO2 emissions (% of total fuel combustion) in China in 2011 and the CO2 emissions (% of total fuel combustion) in Korea (Democratic) in 2012?
Provide a succinct answer. 4.85. What is the difference between the CO2 emissions (% of total fuel combustion) of China in 2011 and the CO2 emissions (% of total fuel combustion) of Zambia in 2012?
Make the answer very short. 2.22. What is the difference between the CO2 emissions (% of total fuel combustion) in Korea (Democratic) in 2011 and the CO2 emissions (% of total fuel combustion) in Zambia in 2012?
Your answer should be compact. -2.63. What is the average CO2 emissions (% of total fuel combustion) in High income per year?
Provide a short and direct response. 10.94. What is the average CO2 emissions (% of total fuel combustion) in China per year?
Keep it short and to the point. 5.57. What is the average CO2 emissions (% of total fuel combustion) of Korea (Democratic) per year?
Keep it short and to the point. 0.18. What is the average CO2 emissions (% of total fuel combustion) of Zambia per year?
Keep it short and to the point. 3.47. In the year 2005, what is the difference between the CO2 emissions (% of total fuel combustion) in High income and CO2 emissions (% of total fuel combustion) in China?
Make the answer very short. 5.17. In the year 2005, what is the difference between the CO2 emissions (% of total fuel combustion) in High income and CO2 emissions (% of total fuel combustion) in Korea (Democratic)?
Your response must be concise. 11.35. In the year 2005, what is the difference between the CO2 emissions (% of total fuel combustion) in High income and CO2 emissions (% of total fuel combustion) in Zambia?
Offer a terse response. 4.79. In the year 2005, what is the difference between the CO2 emissions (% of total fuel combustion) in China and CO2 emissions (% of total fuel combustion) in Korea (Democratic)?
Keep it short and to the point. 6.18. In the year 2005, what is the difference between the CO2 emissions (% of total fuel combustion) of China and CO2 emissions (% of total fuel combustion) of Zambia?
Provide a succinct answer. -0.38. In the year 2005, what is the difference between the CO2 emissions (% of total fuel combustion) of Korea (Democratic) and CO2 emissions (% of total fuel combustion) of Zambia?
Keep it short and to the point. -6.56. In the year 2006, what is the difference between the CO2 emissions (% of total fuel combustion) of High income and CO2 emissions (% of total fuel combustion) of China?
Offer a terse response. 4.93. In the year 2006, what is the difference between the CO2 emissions (% of total fuel combustion) of High income and CO2 emissions (% of total fuel combustion) of Korea (Democratic)?
Your response must be concise. 10.87. In the year 2006, what is the difference between the CO2 emissions (% of total fuel combustion) in High income and CO2 emissions (% of total fuel combustion) in Zambia?
Provide a succinct answer. 8.47. In the year 2006, what is the difference between the CO2 emissions (% of total fuel combustion) in China and CO2 emissions (% of total fuel combustion) in Korea (Democratic)?
Provide a succinct answer. 5.94. In the year 2006, what is the difference between the CO2 emissions (% of total fuel combustion) in China and CO2 emissions (% of total fuel combustion) in Zambia?
Your response must be concise. 3.54. In the year 2006, what is the difference between the CO2 emissions (% of total fuel combustion) in Korea (Democratic) and CO2 emissions (% of total fuel combustion) in Zambia?
Offer a very short reply. -2.41. In the year 2007, what is the difference between the CO2 emissions (% of total fuel combustion) in High income and CO2 emissions (% of total fuel combustion) in China?
Give a very brief answer. 4.7. In the year 2007, what is the difference between the CO2 emissions (% of total fuel combustion) in High income and CO2 emissions (% of total fuel combustion) in Korea (Democratic)?
Provide a succinct answer. 10.45. In the year 2007, what is the difference between the CO2 emissions (% of total fuel combustion) of High income and CO2 emissions (% of total fuel combustion) of Zambia?
Ensure brevity in your answer.  7.78. In the year 2007, what is the difference between the CO2 emissions (% of total fuel combustion) of China and CO2 emissions (% of total fuel combustion) of Korea (Democratic)?
Offer a very short reply. 5.75. In the year 2007, what is the difference between the CO2 emissions (% of total fuel combustion) of China and CO2 emissions (% of total fuel combustion) of Zambia?
Ensure brevity in your answer.  3.08. In the year 2007, what is the difference between the CO2 emissions (% of total fuel combustion) of Korea (Democratic) and CO2 emissions (% of total fuel combustion) of Zambia?
Your answer should be very brief. -2.67. In the year 2008, what is the difference between the CO2 emissions (% of total fuel combustion) of High income and CO2 emissions (% of total fuel combustion) of China?
Keep it short and to the point. 5.64. In the year 2008, what is the difference between the CO2 emissions (% of total fuel combustion) of High income and CO2 emissions (% of total fuel combustion) of Korea (Democratic)?
Ensure brevity in your answer.  10.93. In the year 2008, what is the difference between the CO2 emissions (% of total fuel combustion) in High income and CO2 emissions (% of total fuel combustion) in Zambia?
Your answer should be very brief. 7.97. In the year 2008, what is the difference between the CO2 emissions (% of total fuel combustion) in China and CO2 emissions (% of total fuel combustion) in Korea (Democratic)?
Keep it short and to the point. 5.29. In the year 2008, what is the difference between the CO2 emissions (% of total fuel combustion) in China and CO2 emissions (% of total fuel combustion) in Zambia?
Offer a very short reply. 2.33. In the year 2008, what is the difference between the CO2 emissions (% of total fuel combustion) in Korea (Democratic) and CO2 emissions (% of total fuel combustion) in Zambia?
Offer a very short reply. -2.96. In the year 2009, what is the difference between the CO2 emissions (% of total fuel combustion) of High income and CO2 emissions (% of total fuel combustion) of China?
Your answer should be compact. 6.06. In the year 2009, what is the difference between the CO2 emissions (% of total fuel combustion) in High income and CO2 emissions (% of total fuel combustion) in Korea (Democratic)?
Give a very brief answer. 11.23. In the year 2009, what is the difference between the CO2 emissions (% of total fuel combustion) of High income and CO2 emissions (% of total fuel combustion) of Zambia?
Give a very brief answer. 8.42. In the year 2009, what is the difference between the CO2 emissions (% of total fuel combustion) of China and CO2 emissions (% of total fuel combustion) of Korea (Democratic)?
Make the answer very short. 5.18. In the year 2009, what is the difference between the CO2 emissions (% of total fuel combustion) in China and CO2 emissions (% of total fuel combustion) in Zambia?
Provide a short and direct response. 2.36. In the year 2009, what is the difference between the CO2 emissions (% of total fuel combustion) of Korea (Democratic) and CO2 emissions (% of total fuel combustion) of Zambia?
Offer a terse response. -2.82. In the year 2010, what is the difference between the CO2 emissions (% of total fuel combustion) in High income and CO2 emissions (% of total fuel combustion) in China?
Your response must be concise. 5.86. In the year 2010, what is the difference between the CO2 emissions (% of total fuel combustion) of High income and CO2 emissions (% of total fuel combustion) of Korea (Democratic)?
Give a very brief answer. 10.94. In the year 2010, what is the difference between the CO2 emissions (% of total fuel combustion) of High income and CO2 emissions (% of total fuel combustion) of Zambia?
Provide a short and direct response. 7.7. In the year 2010, what is the difference between the CO2 emissions (% of total fuel combustion) of China and CO2 emissions (% of total fuel combustion) of Korea (Democratic)?
Give a very brief answer. 5.08. In the year 2010, what is the difference between the CO2 emissions (% of total fuel combustion) in China and CO2 emissions (% of total fuel combustion) in Zambia?
Give a very brief answer. 1.84. In the year 2010, what is the difference between the CO2 emissions (% of total fuel combustion) in Korea (Democratic) and CO2 emissions (% of total fuel combustion) in Zambia?
Provide a short and direct response. -3.24. In the year 2011, what is the difference between the CO2 emissions (% of total fuel combustion) of High income and CO2 emissions (% of total fuel combustion) of China?
Provide a succinct answer. 5.43. In the year 2011, what is the difference between the CO2 emissions (% of total fuel combustion) of High income and CO2 emissions (% of total fuel combustion) of Korea (Democratic)?
Keep it short and to the point. 10.28. In the year 2011, what is the difference between the CO2 emissions (% of total fuel combustion) of High income and CO2 emissions (% of total fuel combustion) of Zambia?
Offer a very short reply. 7.23. In the year 2011, what is the difference between the CO2 emissions (% of total fuel combustion) of China and CO2 emissions (% of total fuel combustion) of Korea (Democratic)?
Keep it short and to the point. 4.85. In the year 2011, what is the difference between the CO2 emissions (% of total fuel combustion) in China and CO2 emissions (% of total fuel combustion) in Zambia?
Keep it short and to the point. 1.8. In the year 2011, what is the difference between the CO2 emissions (% of total fuel combustion) in Korea (Democratic) and CO2 emissions (% of total fuel combustion) in Zambia?
Provide a short and direct response. -3.05. In the year 2012, what is the difference between the CO2 emissions (% of total fuel combustion) of High income and CO2 emissions (% of total fuel combustion) of China?
Offer a terse response. 5.2. In the year 2012, what is the difference between the CO2 emissions (% of total fuel combustion) in High income and CO2 emissions (% of total fuel combustion) in Korea (Democratic)?
Provide a succinct answer. 10.08. In the year 2012, what is the difference between the CO2 emissions (% of total fuel combustion) of High income and CO2 emissions (% of total fuel combustion) of Zambia?
Provide a short and direct response. 7.45. In the year 2012, what is the difference between the CO2 emissions (% of total fuel combustion) in China and CO2 emissions (% of total fuel combustion) in Korea (Democratic)?
Your answer should be compact. 4.89. In the year 2012, what is the difference between the CO2 emissions (% of total fuel combustion) in China and CO2 emissions (% of total fuel combustion) in Zambia?
Offer a terse response. 2.25. In the year 2012, what is the difference between the CO2 emissions (% of total fuel combustion) in Korea (Democratic) and CO2 emissions (% of total fuel combustion) in Zambia?
Make the answer very short. -2.63. What is the ratio of the CO2 emissions (% of total fuel combustion) of High income in 2005 to that in 2006?
Your response must be concise. 1.05. What is the ratio of the CO2 emissions (% of total fuel combustion) of China in 2005 to that in 2006?
Make the answer very short. 1.04. What is the ratio of the CO2 emissions (% of total fuel combustion) of Korea (Democratic) in 2005 to that in 2006?
Give a very brief answer. 1.27. What is the ratio of the CO2 emissions (% of total fuel combustion) in Zambia in 2005 to that in 2006?
Your answer should be very brief. 2.67. What is the ratio of the CO2 emissions (% of total fuel combustion) in High income in 2005 to that in 2007?
Your answer should be very brief. 1.08. What is the ratio of the CO2 emissions (% of total fuel combustion) of China in 2005 to that in 2007?
Give a very brief answer. 1.07. What is the ratio of the CO2 emissions (% of total fuel combustion) in Korea (Democratic) in 2005 to that in 2007?
Give a very brief answer. 0.93. What is the ratio of the CO2 emissions (% of total fuel combustion) in Zambia in 2005 to that in 2007?
Make the answer very short. 2.38. What is the ratio of the CO2 emissions (% of total fuel combustion) in High income in 2005 to that in 2008?
Your response must be concise. 1.04. What is the ratio of the CO2 emissions (% of total fuel combustion) of China in 2005 to that in 2008?
Keep it short and to the point. 1.16. What is the ratio of the CO2 emissions (% of total fuel combustion) of Korea (Democratic) in 2005 to that in 2008?
Your response must be concise. 0.93. What is the ratio of the CO2 emissions (% of total fuel combustion) of Zambia in 2005 to that in 2008?
Ensure brevity in your answer.  2.16. What is the ratio of the CO2 emissions (% of total fuel combustion) in High income in 2005 to that in 2009?
Provide a short and direct response. 1.01. What is the ratio of the CO2 emissions (% of total fuel combustion) of China in 2005 to that in 2009?
Provide a short and direct response. 1.18. What is the ratio of the CO2 emissions (% of total fuel combustion) in Korea (Democratic) in 2005 to that in 2009?
Make the answer very short. 0.84. What is the ratio of the CO2 emissions (% of total fuel combustion) in Zambia in 2005 to that in 2009?
Ensure brevity in your answer.  2.25. What is the ratio of the CO2 emissions (% of total fuel combustion) of High income in 2005 to that in 2010?
Give a very brief answer. 1.03. What is the ratio of the CO2 emissions (% of total fuel combustion) of China in 2005 to that in 2010?
Keep it short and to the point. 1.2. What is the ratio of the CO2 emissions (% of total fuel combustion) of Korea (Democratic) in 2005 to that in 2010?
Offer a terse response. 0.73. What is the ratio of the CO2 emissions (% of total fuel combustion) in Zambia in 2005 to that in 2010?
Your answer should be compact. 1.95. What is the ratio of the CO2 emissions (% of total fuel combustion) of High income in 2005 to that in 2011?
Keep it short and to the point. 1.09. What is the ratio of the CO2 emissions (% of total fuel combustion) in China in 2005 to that in 2011?
Your response must be concise. 1.24. What is the ratio of the CO2 emissions (% of total fuel combustion) in Korea (Democratic) in 2005 to that in 2011?
Make the answer very short. 0.51. What is the ratio of the CO2 emissions (% of total fuel combustion) of Zambia in 2005 to that in 2011?
Your response must be concise. 2.02. What is the ratio of the CO2 emissions (% of total fuel combustion) of High income in 2005 to that in 2012?
Provide a short and direct response. 1.11. What is the ratio of the CO2 emissions (% of total fuel combustion) of China in 2005 to that in 2012?
Ensure brevity in your answer.  1.23. What is the ratio of the CO2 emissions (% of total fuel combustion) in Korea (Democratic) in 2005 to that in 2012?
Your response must be concise. 0.51. What is the ratio of the CO2 emissions (% of total fuel combustion) of Zambia in 2005 to that in 2012?
Make the answer very short. 2.31. What is the ratio of the CO2 emissions (% of total fuel combustion) of High income in 2006 to that in 2007?
Ensure brevity in your answer.  1.04. What is the ratio of the CO2 emissions (% of total fuel combustion) of China in 2006 to that in 2007?
Your answer should be very brief. 1.03. What is the ratio of the CO2 emissions (% of total fuel combustion) of Korea (Democratic) in 2006 to that in 2007?
Offer a very short reply. 0.73. What is the ratio of the CO2 emissions (% of total fuel combustion) of Zambia in 2006 to that in 2007?
Give a very brief answer. 0.89. What is the ratio of the CO2 emissions (% of total fuel combustion) of China in 2006 to that in 2008?
Give a very brief answer. 1.11. What is the ratio of the CO2 emissions (% of total fuel combustion) of Korea (Democratic) in 2006 to that in 2008?
Make the answer very short. 0.74. What is the ratio of the CO2 emissions (% of total fuel combustion) in Zambia in 2006 to that in 2008?
Your answer should be very brief. 0.81. What is the ratio of the CO2 emissions (% of total fuel combustion) in High income in 2006 to that in 2009?
Your answer should be compact. 0.96. What is the ratio of the CO2 emissions (% of total fuel combustion) in China in 2006 to that in 2009?
Give a very brief answer. 1.13. What is the ratio of the CO2 emissions (% of total fuel combustion) in Korea (Democratic) in 2006 to that in 2009?
Offer a very short reply. 0.66. What is the ratio of the CO2 emissions (% of total fuel combustion) of Zambia in 2006 to that in 2009?
Provide a short and direct response. 0.84. What is the ratio of the CO2 emissions (% of total fuel combustion) in China in 2006 to that in 2010?
Provide a short and direct response. 1.15. What is the ratio of the CO2 emissions (% of total fuel combustion) of Korea (Democratic) in 2006 to that in 2010?
Keep it short and to the point. 0.57. What is the ratio of the CO2 emissions (% of total fuel combustion) in Zambia in 2006 to that in 2010?
Keep it short and to the point. 0.73. What is the ratio of the CO2 emissions (% of total fuel combustion) in High income in 2006 to that in 2011?
Your answer should be compact. 1.04. What is the ratio of the CO2 emissions (% of total fuel combustion) in China in 2006 to that in 2011?
Provide a succinct answer. 1.18. What is the ratio of the CO2 emissions (% of total fuel combustion) in Korea (Democratic) in 2006 to that in 2011?
Keep it short and to the point. 0.4. What is the ratio of the CO2 emissions (% of total fuel combustion) of Zambia in 2006 to that in 2011?
Offer a terse response. 0.76. What is the ratio of the CO2 emissions (% of total fuel combustion) in High income in 2006 to that in 2012?
Give a very brief answer. 1.06. What is the ratio of the CO2 emissions (% of total fuel combustion) in China in 2006 to that in 2012?
Offer a terse response. 1.17. What is the ratio of the CO2 emissions (% of total fuel combustion) of Korea (Democratic) in 2006 to that in 2012?
Provide a succinct answer. 0.4. What is the ratio of the CO2 emissions (% of total fuel combustion) of Zambia in 2006 to that in 2012?
Provide a short and direct response. 0.87. What is the ratio of the CO2 emissions (% of total fuel combustion) in High income in 2007 to that in 2008?
Make the answer very short. 0.96. What is the ratio of the CO2 emissions (% of total fuel combustion) in China in 2007 to that in 2008?
Offer a terse response. 1.08. What is the ratio of the CO2 emissions (% of total fuel combustion) of Korea (Democratic) in 2007 to that in 2008?
Your answer should be very brief. 1. What is the ratio of the CO2 emissions (% of total fuel combustion) in Zambia in 2007 to that in 2008?
Keep it short and to the point. 0.91. What is the ratio of the CO2 emissions (% of total fuel combustion) in High income in 2007 to that in 2009?
Give a very brief answer. 0.93. What is the ratio of the CO2 emissions (% of total fuel combustion) of China in 2007 to that in 2009?
Your response must be concise. 1.1. What is the ratio of the CO2 emissions (% of total fuel combustion) of Korea (Democratic) in 2007 to that in 2009?
Offer a very short reply. 0.9. What is the ratio of the CO2 emissions (% of total fuel combustion) of Zambia in 2007 to that in 2009?
Keep it short and to the point. 0.95. What is the ratio of the CO2 emissions (% of total fuel combustion) in High income in 2007 to that in 2010?
Your answer should be very brief. 0.95. What is the ratio of the CO2 emissions (% of total fuel combustion) in China in 2007 to that in 2010?
Give a very brief answer. 1.12. What is the ratio of the CO2 emissions (% of total fuel combustion) of Korea (Democratic) in 2007 to that in 2010?
Provide a succinct answer. 0.78. What is the ratio of the CO2 emissions (% of total fuel combustion) in Zambia in 2007 to that in 2010?
Keep it short and to the point. 0.82. What is the ratio of the CO2 emissions (% of total fuel combustion) of High income in 2007 to that in 2011?
Give a very brief answer. 1.01. What is the ratio of the CO2 emissions (% of total fuel combustion) in China in 2007 to that in 2011?
Offer a terse response. 1.15. What is the ratio of the CO2 emissions (% of total fuel combustion) in Korea (Democratic) in 2007 to that in 2011?
Keep it short and to the point. 0.55. What is the ratio of the CO2 emissions (% of total fuel combustion) of Zambia in 2007 to that in 2011?
Give a very brief answer. 0.85. What is the ratio of the CO2 emissions (% of total fuel combustion) in High income in 2007 to that in 2012?
Your answer should be compact. 1.02. What is the ratio of the CO2 emissions (% of total fuel combustion) of China in 2007 to that in 2012?
Give a very brief answer. 1.14. What is the ratio of the CO2 emissions (% of total fuel combustion) of Korea (Democratic) in 2007 to that in 2012?
Keep it short and to the point. 0.55. What is the ratio of the CO2 emissions (% of total fuel combustion) of Zambia in 2007 to that in 2012?
Your response must be concise. 0.97. What is the ratio of the CO2 emissions (% of total fuel combustion) of China in 2008 to that in 2009?
Provide a short and direct response. 1.02. What is the ratio of the CO2 emissions (% of total fuel combustion) in Korea (Democratic) in 2008 to that in 2009?
Your answer should be compact. 0.9. What is the ratio of the CO2 emissions (% of total fuel combustion) of Zambia in 2008 to that in 2009?
Provide a short and direct response. 1.04. What is the ratio of the CO2 emissions (% of total fuel combustion) of High income in 2008 to that in 2010?
Offer a terse response. 1. What is the ratio of the CO2 emissions (% of total fuel combustion) in China in 2008 to that in 2010?
Make the answer very short. 1.03. What is the ratio of the CO2 emissions (% of total fuel combustion) in Korea (Democratic) in 2008 to that in 2010?
Your answer should be compact. 0.78. What is the ratio of the CO2 emissions (% of total fuel combustion) in Zambia in 2008 to that in 2010?
Your answer should be compact. 0.91. What is the ratio of the CO2 emissions (% of total fuel combustion) in High income in 2008 to that in 2011?
Make the answer very short. 1.05. What is the ratio of the CO2 emissions (% of total fuel combustion) of China in 2008 to that in 2011?
Offer a very short reply. 1.06. What is the ratio of the CO2 emissions (% of total fuel combustion) of Korea (Democratic) in 2008 to that in 2011?
Provide a short and direct response. 0.55. What is the ratio of the CO2 emissions (% of total fuel combustion) in Zambia in 2008 to that in 2011?
Your response must be concise. 0.94. What is the ratio of the CO2 emissions (% of total fuel combustion) of High income in 2008 to that in 2012?
Your answer should be very brief. 1.07. What is the ratio of the CO2 emissions (% of total fuel combustion) in China in 2008 to that in 2012?
Ensure brevity in your answer.  1.06. What is the ratio of the CO2 emissions (% of total fuel combustion) of Korea (Democratic) in 2008 to that in 2012?
Your answer should be compact. 0.55. What is the ratio of the CO2 emissions (% of total fuel combustion) in Zambia in 2008 to that in 2012?
Your answer should be compact. 1.07. What is the ratio of the CO2 emissions (% of total fuel combustion) in High income in 2009 to that in 2010?
Keep it short and to the point. 1.02. What is the ratio of the CO2 emissions (% of total fuel combustion) of China in 2009 to that in 2010?
Provide a succinct answer. 1.01. What is the ratio of the CO2 emissions (% of total fuel combustion) in Korea (Democratic) in 2009 to that in 2010?
Your answer should be very brief. 0.86. What is the ratio of the CO2 emissions (% of total fuel combustion) of Zambia in 2009 to that in 2010?
Provide a succinct answer. 0.87. What is the ratio of the CO2 emissions (% of total fuel combustion) of High income in 2009 to that in 2011?
Provide a short and direct response. 1.08. What is the ratio of the CO2 emissions (% of total fuel combustion) of China in 2009 to that in 2011?
Your response must be concise. 1.04. What is the ratio of the CO2 emissions (% of total fuel combustion) in Korea (Democratic) in 2009 to that in 2011?
Keep it short and to the point. 0.6. What is the ratio of the CO2 emissions (% of total fuel combustion) in Zambia in 2009 to that in 2011?
Make the answer very short. 0.9. What is the ratio of the CO2 emissions (% of total fuel combustion) of High income in 2009 to that in 2012?
Keep it short and to the point. 1.1. What is the ratio of the CO2 emissions (% of total fuel combustion) of China in 2009 to that in 2012?
Give a very brief answer. 1.04. What is the ratio of the CO2 emissions (% of total fuel combustion) in Korea (Democratic) in 2009 to that in 2012?
Your answer should be compact. 0.61. What is the ratio of the CO2 emissions (% of total fuel combustion) of Zambia in 2009 to that in 2012?
Offer a terse response. 1.03. What is the ratio of the CO2 emissions (% of total fuel combustion) of High income in 2010 to that in 2011?
Provide a succinct answer. 1.06. What is the ratio of the CO2 emissions (% of total fuel combustion) of China in 2010 to that in 2011?
Keep it short and to the point. 1.03. What is the ratio of the CO2 emissions (% of total fuel combustion) of Korea (Democratic) in 2010 to that in 2011?
Provide a succinct answer. 0.7. What is the ratio of the CO2 emissions (% of total fuel combustion) in Zambia in 2010 to that in 2011?
Give a very brief answer. 1.03. What is the ratio of the CO2 emissions (% of total fuel combustion) of High income in 2010 to that in 2012?
Provide a short and direct response. 1.08. What is the ratio of the CO2 emissions (% of total fuel combustion) of China in 2010 to that in 2012?
Provide a short and direct response. 1.02. What is the ratio of the CO2 emissions (% of total fuel combustion) in Korea (Democratic) in 2010 to that in 2012?
Offer a terse response. 0.71. What is the ratio of the CO2 emissions (% of total fuel combustion) of Zambia in 2010 to that in 2012?
Give a very brief answer. 1.18. What is the ratio of the CO2 emissions (% of total fuel combustion) in China in 2011 to that in 2012?
Keep it short and to the point. 0.99. What is the ratio of the CO2 emissions (% of total fuel combustion) of Zambia in 2011 to that in 2012?
Offer a terse response. 1.14. What is the difference between the highest and the second highest CO2 emissions (% of total fuel combustion) in High income?
Provide a short and direct response. 0.09. What is the difference between the highest and the second highest CO2 emissions (% of total fuel combustion) of China?
Give a very brief answer. 0.27. What is the difference between the highest and the second highest CO2 emissions (% of total fuel combustion) in Korea (Democratic)?
Your answer should be very brief. 0. What is the difference between the highest and the second highest CO2 emissions (% of total fuel combustion) in Zambia?
Give a very brief answer. 3.27. What is the difference between the highest and the lowest CO2 emissions (% of total fuel combustion) in High income?
Your answer should be very brief. 1.14. What is the difference between the highest and the lowest CO2 emissions (% of total fuel combustion) in China?
Provide a succinct answer. 1.2. What is the difference between the highest and the lowest CO2 emissions (% of total fuel combustion) in Korea (Democratic)?
Provide a short and direct response. 0.16. What is the difference between the highest and the lowest CO2 emissions (% of total fuel combustion) in Zambia?
Make the answer very short. 4.19. 